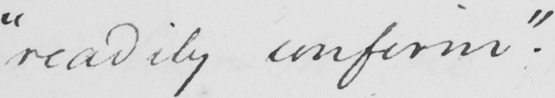Transcribe the text shown in this historical manuscript line. " readily confirm "  . 